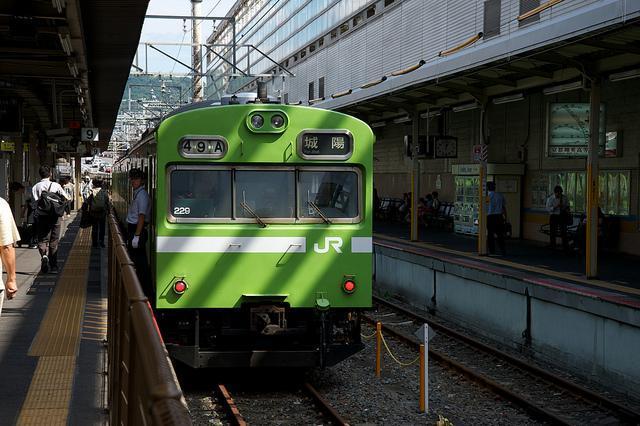How many people are visible?
Give a very brief answer. 2. How many donuts are there?
Give a very brief answer. 0. 